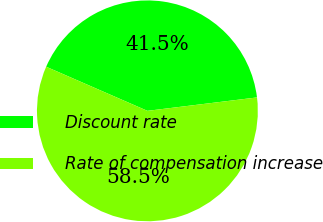Convert chart. <chart><loc_0><loc_0><loc_500><loc_500><pie_chart><fcel>Discount rate<fcel>Rate of compensation increase<nl><fcel>41.52%<fcel>58.48%<nl></chart> 